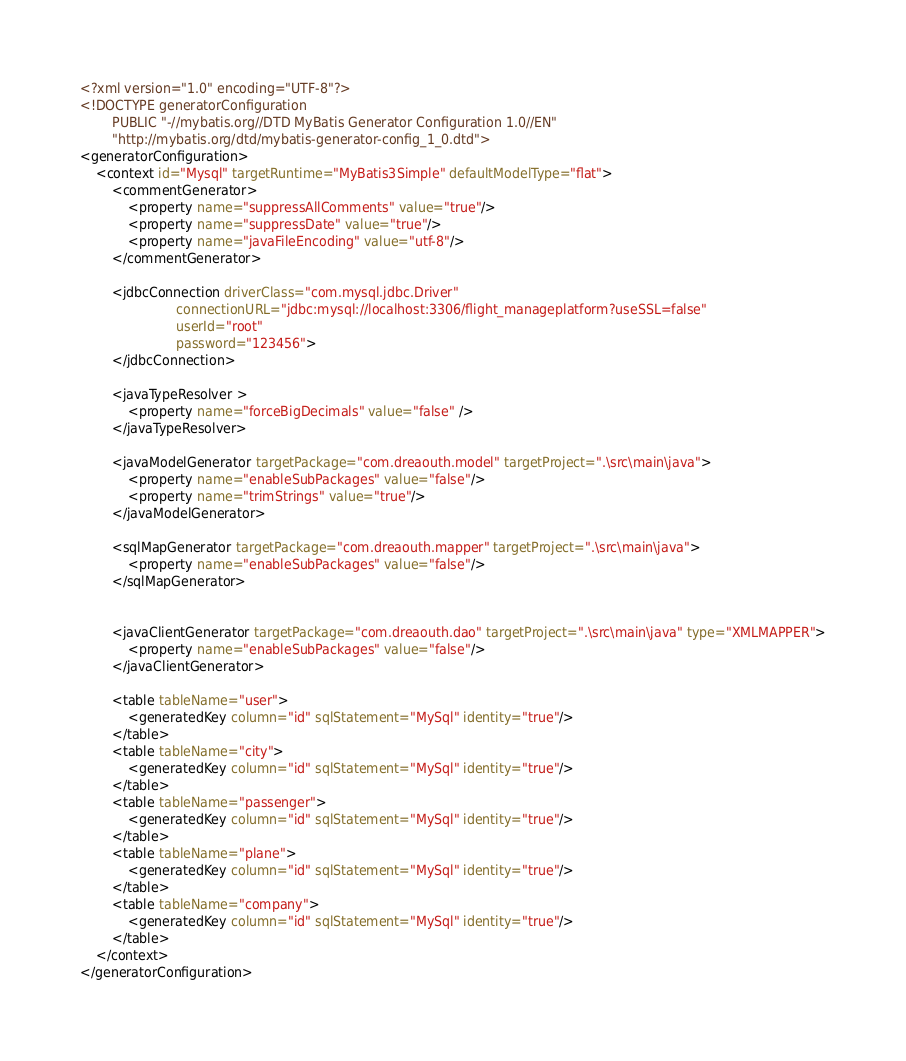<code> <loc_0><loc_0><loc_500><loc_500><_XML_><?xml version="1.0" encoding="UTF-8"?>
<!DOCTYPE generatorConfiguration
        PUBLIC "-//mybatis.org//DTD MyBatis Generator Configuration 1.0//EN"
        "http://mybatis.org/dtd/mybatis-generator-config_1_0.dtd">
<generatorConfiguration>
    <context id="Mysql" targetRuntime="MyBatis3Simple" defaultModelType="flat">
        <commentGenerator>
            <property name="suppressAllComments" value="true"/>
            <property name="suppressDate" value="true"/>
            <property name="javaFileEncoding" value="utf-8"/>
        </commentGenerator>

        <jdbcConnection driverClass="com.mysql.jdbc.Driver"
                        connectionURL="jdbc:mysql://localhost:3306/flight_manageplatform?useSSL=false"
                        userId="root"
                        password="123456">
        </jdbcConnection>

        <javaTypeResolver >
            <property name="forceBigDecimals" value="false" />
        </javaTypeResolver>

        <javaModelGenerator targetPackage="com.dreaouth.model" targetProject=".\src\main\java">
            <property name="enableSubPackages" value="false"/>
            <property name="trimStrings" value="true"/>
        </javaModelGenerator>

        <sqlMapGenerator targetPackage="com.dreaouth.mapper" targetProject=".\src\main\java">
            <property name="enableSubPackages" value="false"/>
        </sqlMapGenerator>


        <javaClientGenerator targetPackage="com.dreaouth.dao" targetProject=".\src\main\java" type="XMLMAPPER">
            <property name="enableSubPackages" value="false"/>
        </javaClientGenerator>

        <table tableName="user">
            <generatedKey column="id" sqlStatement="MySql" identity="true"/>
        </table>
        <table tableName="city">
            <generatedKey column="id" sqlStatement="MySql" identity="true"/>
        </table>
        <table tableName="passenger">
            <generatedKey column="id" sqlStatement="MySql" identity="true"/>
        </table>
        <table tableName="plane">
            <generatedKey column="id" sqlStatement="MySql" identity="true"/>
        </table>
        <table tableName="company">
            <generatedKey column="id" sqlStatement="MySql" identity="true"/>
        </table>
    </context>
</generatorConfiguration></code> 